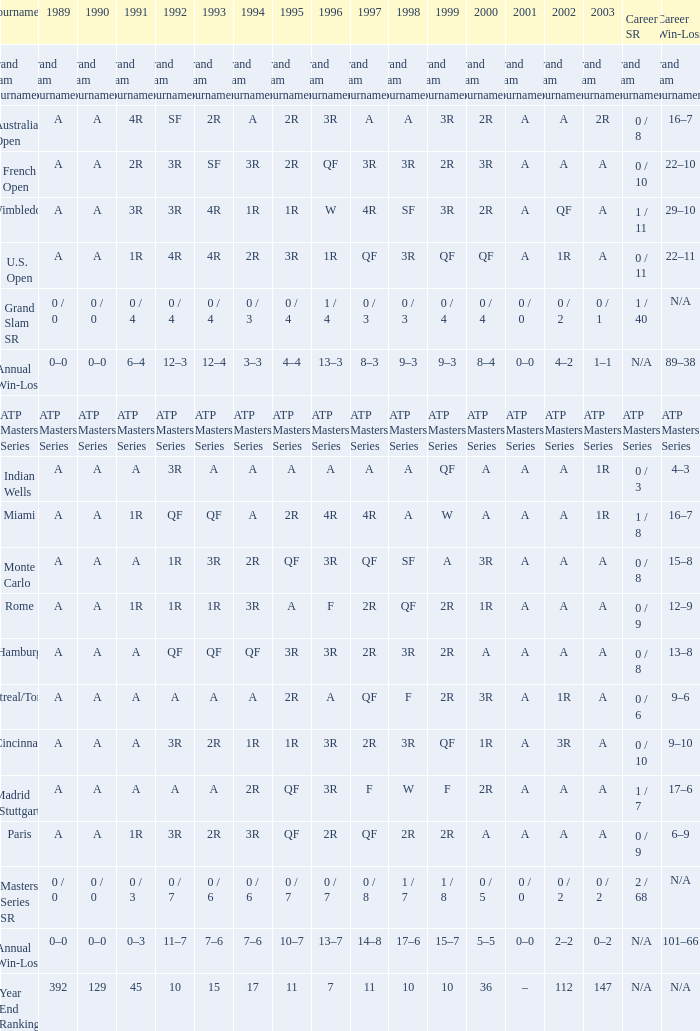What was the value in 1989 with QF in 1997 and A in 1993? A. 